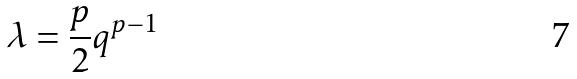<formula> <loc_0><loc_0><loc_500><loc_500>\lambda = \frac { p } { 2 } q ^ { p - 1 }</formula> 